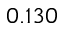<formula> <loc_0><loc_0><loc_500><loc_500>0 . 1 3 0</formula> 